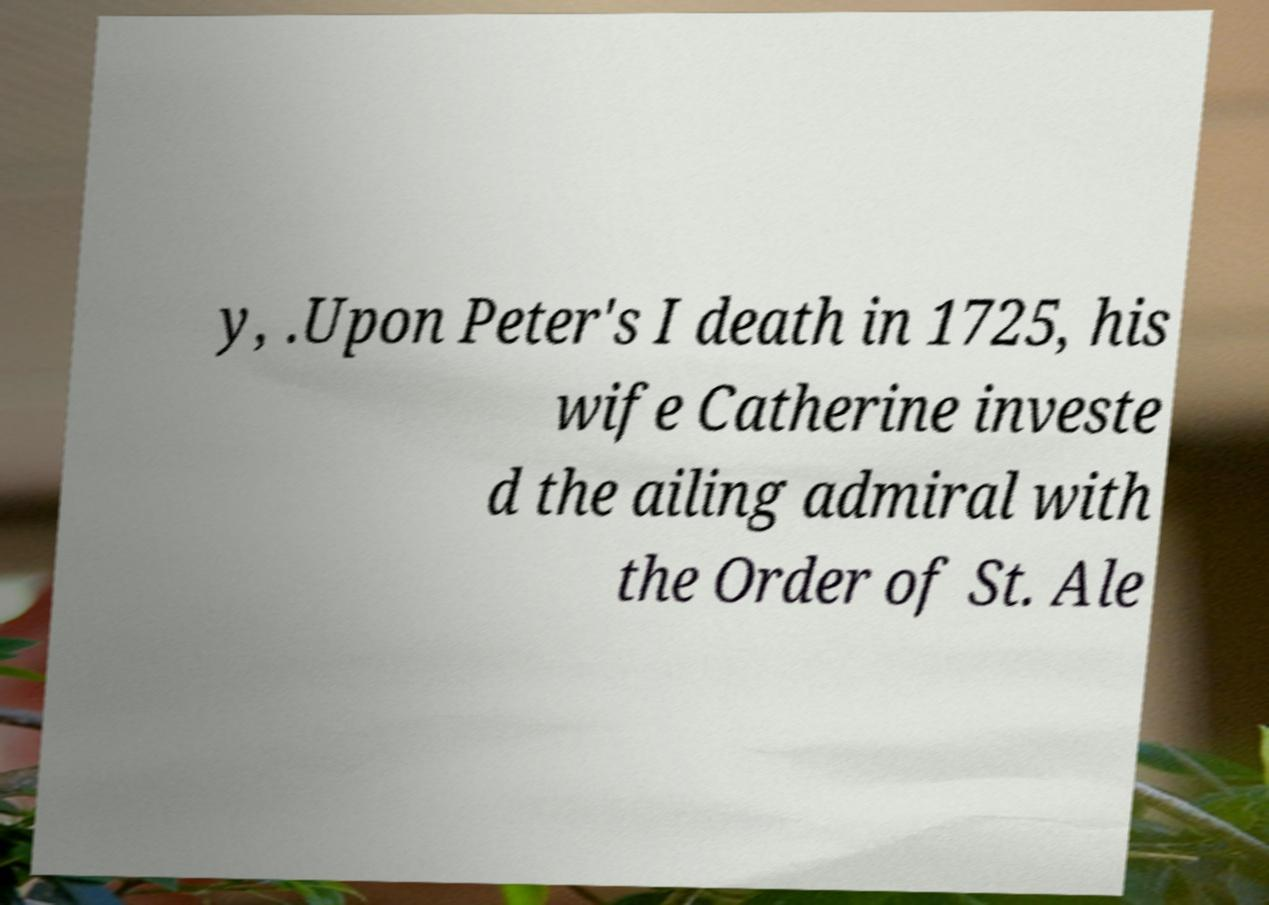Please read and relay the text visible in this image. What does it say? y, .Upon Peter's I death in 1725, his wife Catherine investe d the ailing admiral with the Order of St. Ale 